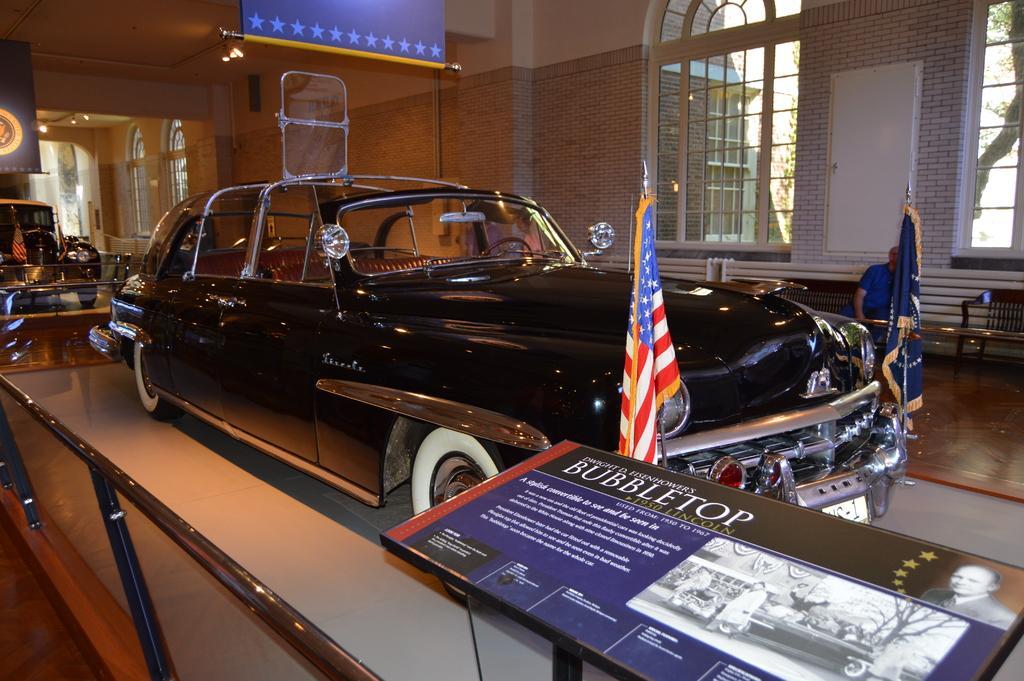In one or two sentences, can you explain what this image depicts? In this picture we can see vehicles, some text and a few things on the boards. We can see flags on the poles visible on the cars. There is a person sitting on a bench. We can see arches, glass objects and other objects. Through these glass objects, we can see a few leaves and other things in the background. 